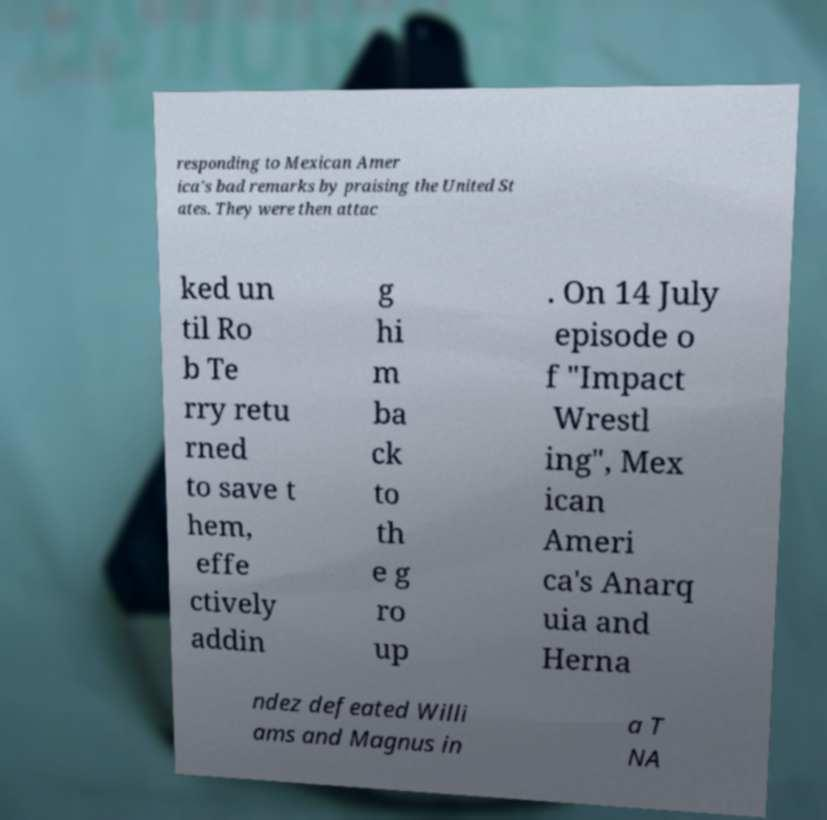Could you assist in decoding the text presented in this image and type it out clearly? responding to Mexican Amer ica's bad remarks by praising the United St ates. They were then attac ked un til Ro b Te rry retu rned to save t hem, effe ctively addin g hi m ba ck to th e g ro up . On 14 July episode o f "Impact Wrestl ing", Mex ican Ameri ca's Anarq uia and Herna ndez defeated Willi ams and Magnus in a T NA 